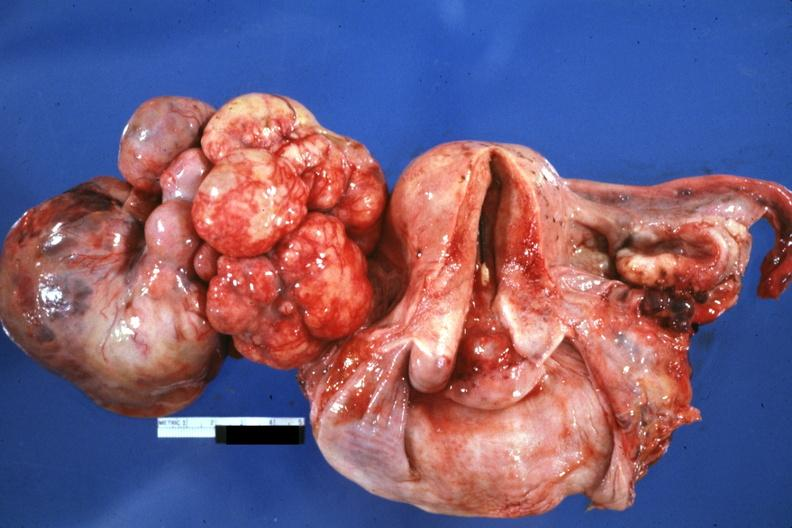where does this belong to?
Answer the question using a single word or phrase. Female reproductive system 